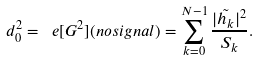Convert formula to latex. <formula><loc_0><loc_0><loc_500><loc_500>d _ { 0 } ^ { 2 } = \ e [ G ^ { 2 } ] ( n o s i g n a l ) = \sum _ { k = 0 } ^ { N - 1 } \frac { | \tilde { h _ { k } } | ^ { 2 } } { S _ { k } } .</formula> 